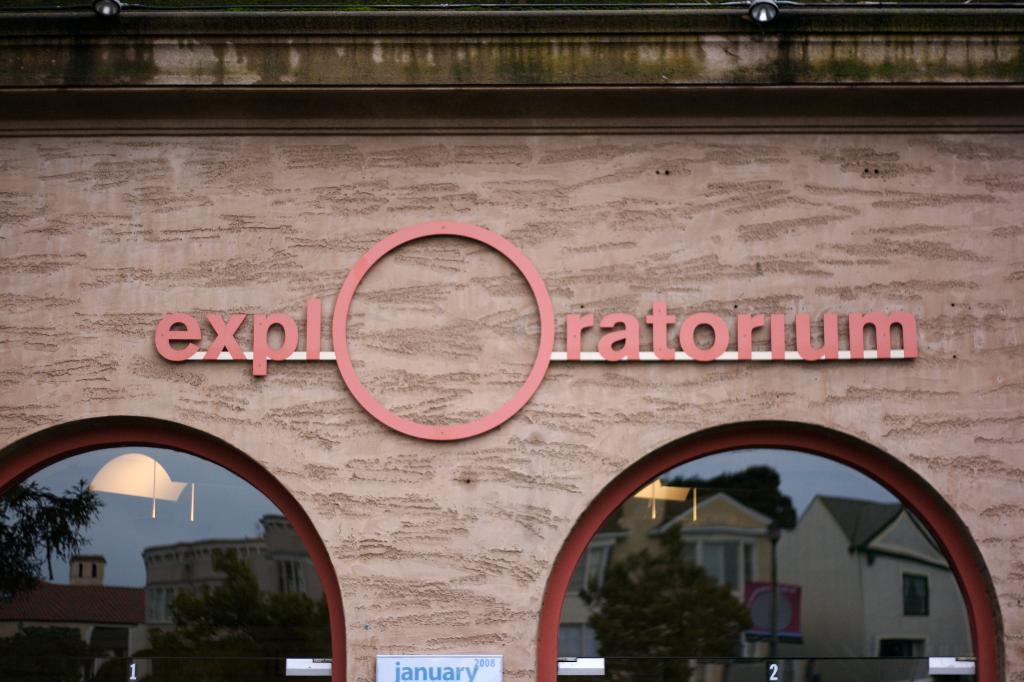How would you summarize this image in a sentence or two? In this image, we can see a board and on the board, there is a name board, there are glasses and through the glass we can see buildings, trees. At the top, there are lights. 